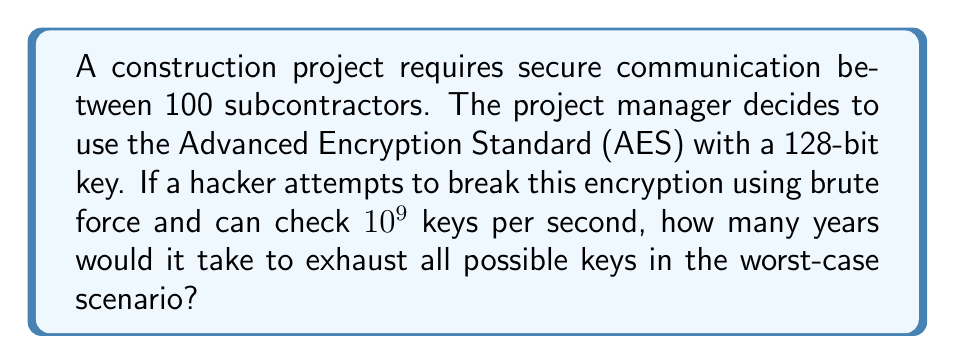Teach me how to tackle this problem. Let's approach this step-by-step:

1. Calculate the total number of possible keys:
   - AES-128 uses a 128-bit key
   - Number of possible keys = $2^{128}$

2. Convert the hacker's speed to keys per year:
   - Keys per second = $10^9$
   - Seconds in a year = $365 \times 24 \times 60 \times 60 = 31,536,000$
   - Keys per year = $10^9 \times 31,536,000 = 3.1536 \times 10^{16}$

3. Calculate the time required to check all keys:
   $$\text{Time (years)} = \frac{\text{Total number of keys}}{\text{Keys checked per year}}$$
   $$= \frac{2^{128}}{3.1536 \times 10^{16}}$$

4. Simplify and calculate:
   $$= \frac{2^{128}}{3.1536 \times 10^{16}}$$
   $$\approx \frac{3.4028 \times 10^{38}}{3.1536 \times 10^{16}}$$
   $$\approx 1.0791 \times 10^{22} \text{ years}$$

This immense number demonstrates the practical impossibility of breaking AES-128 through brute force, ensuring the security of the construction project's communications.
Answer: $1.0791 \times 10^{22}$ years 